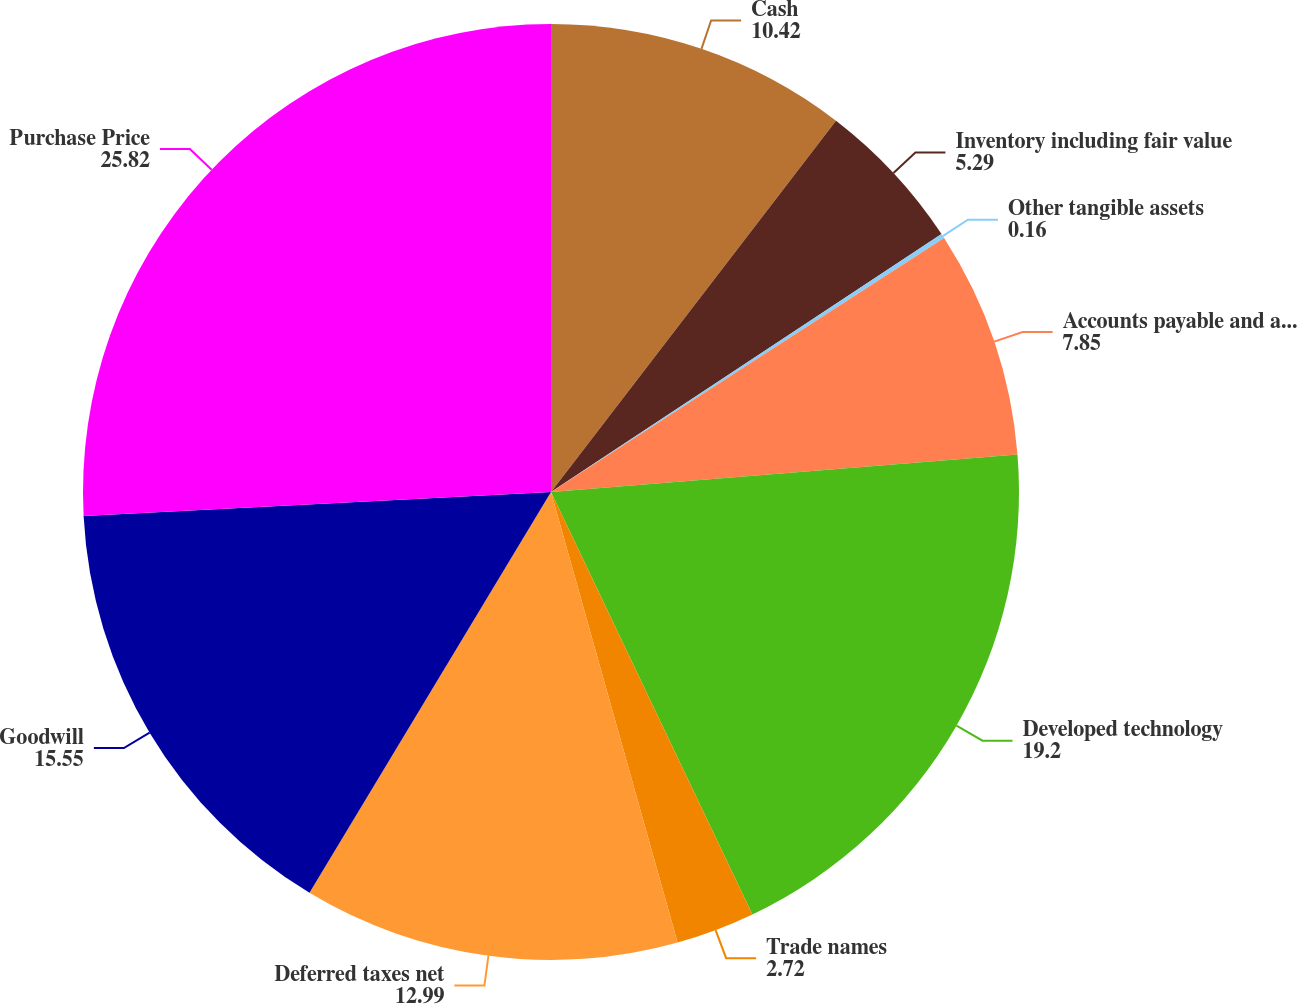<chart> <loc_0><loc_0><loc_500><loc_500><pie_chart><fcel>Cash<fcel>Inventory including fair value<fcel>Other tangible assets<fcel>Accounts payable and accrued<fcel>Developed technology<fcel>Trade names<fcel>Deferred taxes net<fcel>Goodwill<fcel>Purchase Price<nl><fcel>10.42%<fcel>5.29%<fcel>0.16%<fcel>7.85%<fcel>19.2%<fcel>2.72%<fcel>12.99%<fcel>15.55%<fcel>25.82%<nl></chart> 